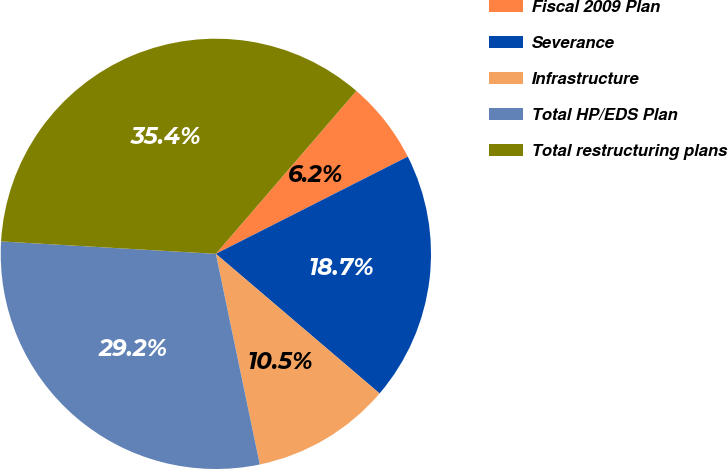<chart> <loc_0><loc_0><loc_500><loc_500><pie_chart><fcel>Fiscal 2009 Plan<fcel>Severance<fcel>Infrastructure<fcel>Total HP/EDS Plan<fcel>Total restructuring plans<nl><fcel>6.21%<fcel>18.7%<fcel>10.49%<fcel>29.19%<fcel>35.4%<nl></chart> 